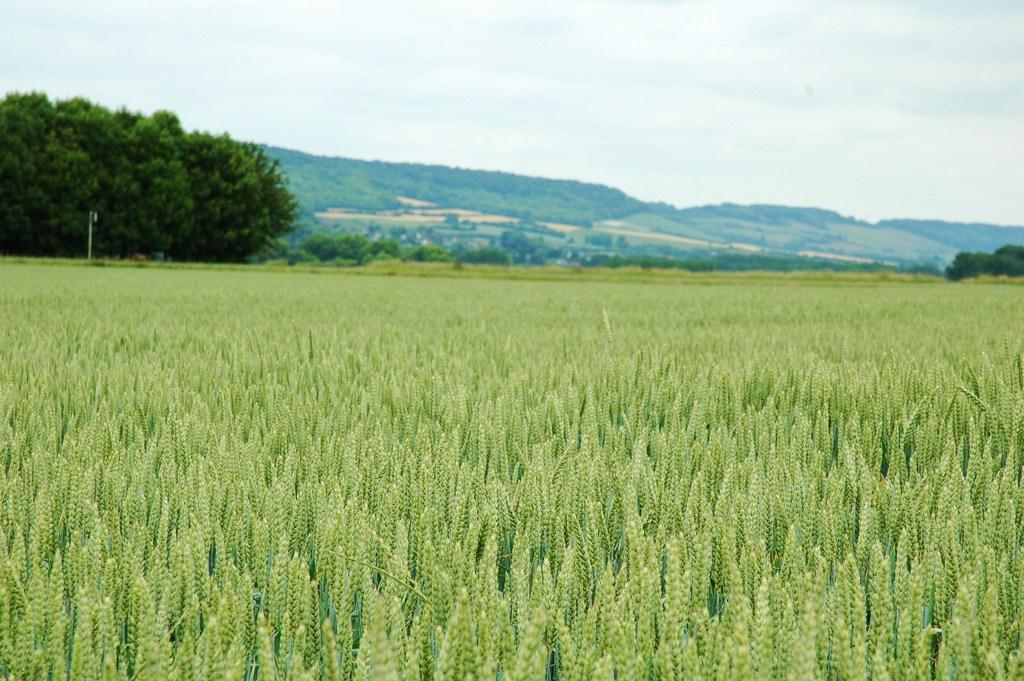What is the main subject of the image? The main subject of the image is a crop. What can be seen in the background of the image? There are trees and a mountain in the background of the image. What is visible above the trees and mountain? The sky is visible in the background of the image. How many tubes of toothpaste are lying on the ground near the crop in the image? There is no mention of toothpaste in the image, so it cannot be determined if any tubes are present. 